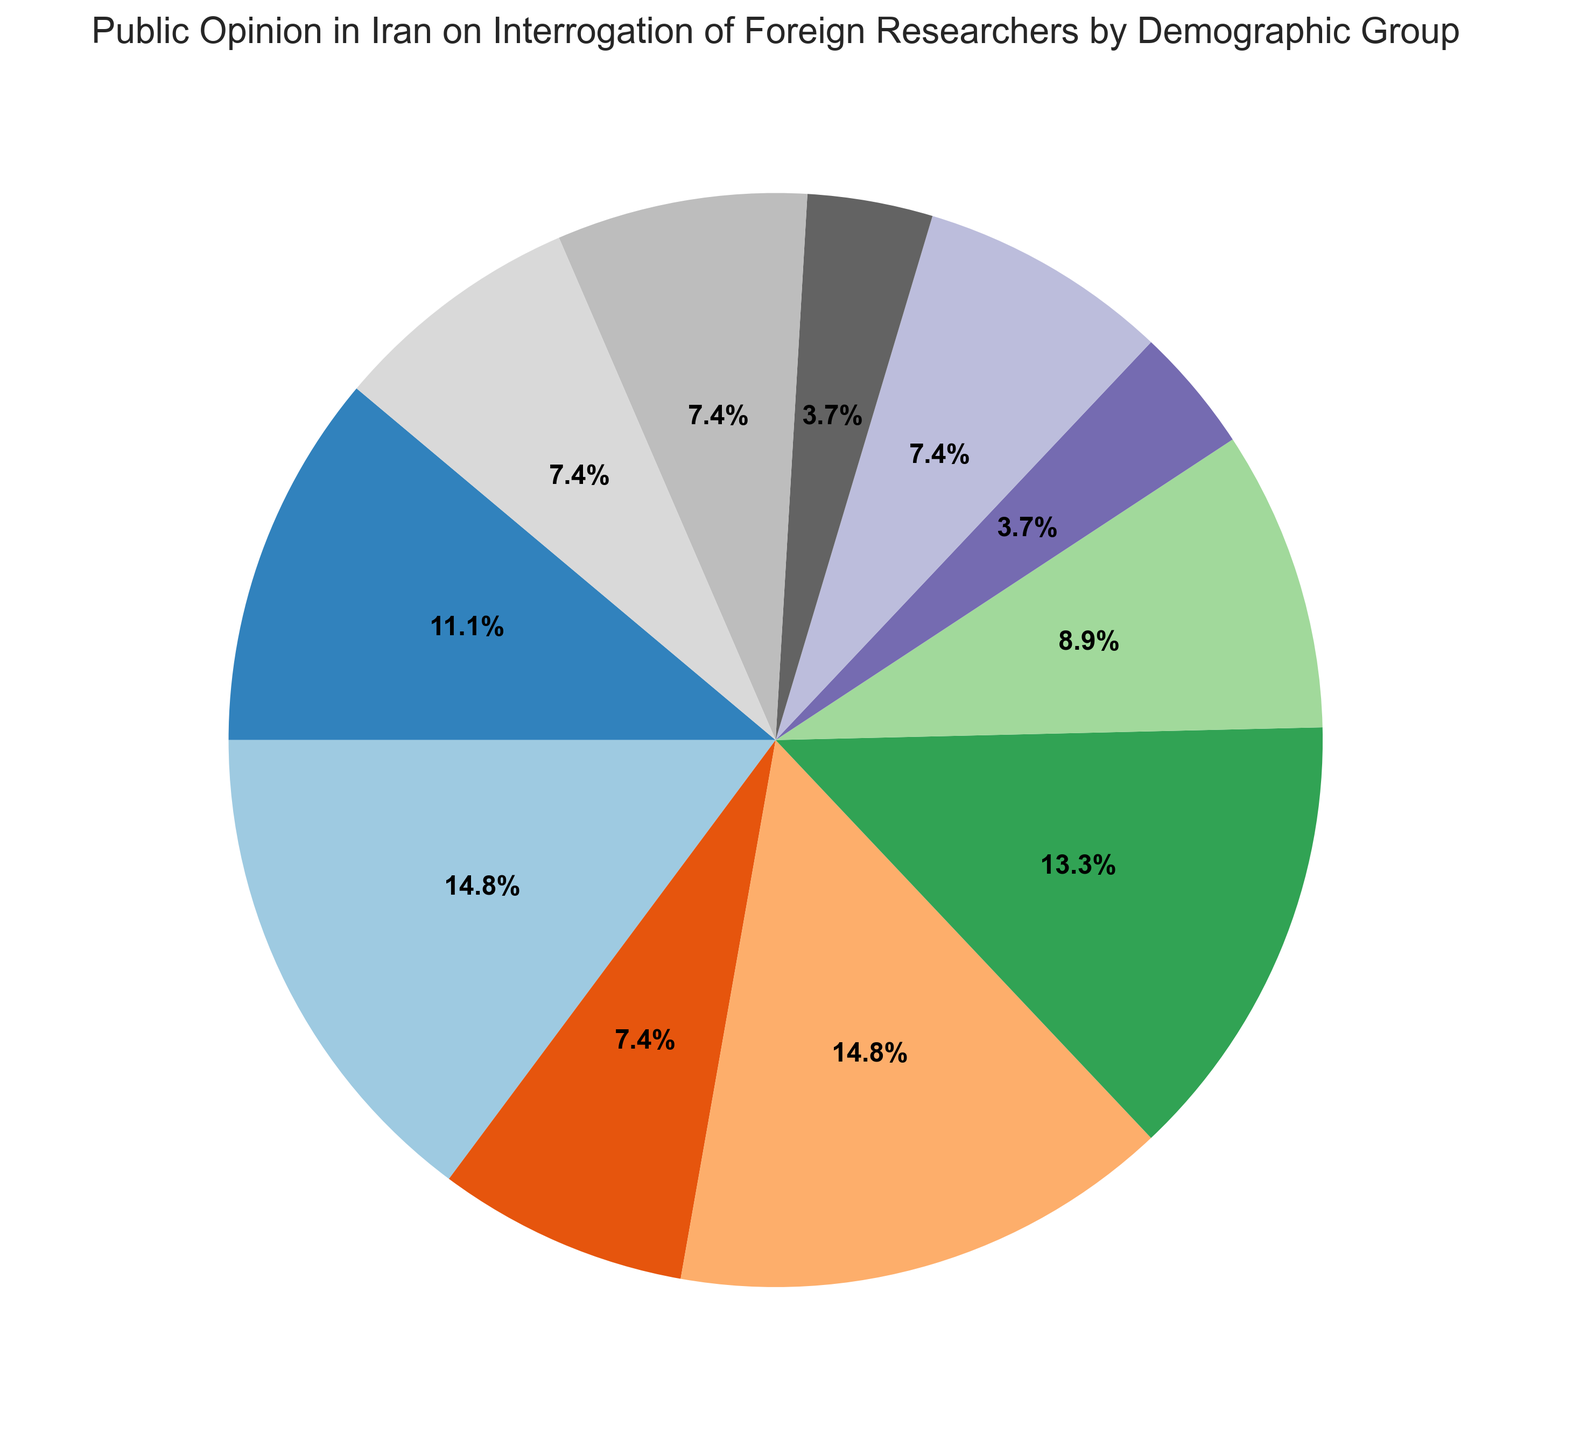Which demographic has the highest percentage of opinion on the interrogation of foreign researchers? Observing the pie chart, the largest wedge or segment corresponds to "Men 30-50" which has a 20% share.
Answer: Men 30-50 Which two demographic groups have the same percentage of opinion, and what is the percentage? By examining the pie chart, it's evident that "Rural residents," "Moderately educated," and "Lowly educated" each hold a 10% share.
Answer: Rural residents and Moderately educated with 10% How does the percentage of opinion for "Women under 30" compare with "Men over 50"? The pie chart shows that "Women under 30" have a percentage of 20%, while "Men over 50" have a percentage of 10%. Therefore, "Women under 30" have double the percentage of "Men over 50".
Answer: Women under 30 have double the percentage of Men over 50 What is the combined percentage for all women demographic groups? The pie chart reveals the percentages for "Women under 30" (20%), "Women 30-50" (18%), and "Women over 50" (12%). The combined percentage is: 20 + 18 + 12 = 50%.
Answer: 50% Compare the total percentage of opinion between urban and rural residents. The pie chart shows that "Urban residents" have 5% while "Rural residents" have 10%. So, "Rural residents" have 5% more than "Urban residents".
Answer: Rural residents have 5% more than Urban residents What percentage difference exists between "Men 30-50" and "Women 30-50"? According to the pie chart, "Men 30-50" account for 20% and "Women 30-50" account for 18%. The percentage difference is: 20 - 18 = 2%.
Answer: 2% Which demographic groups have the lowest percentage, and what is that percentage? Observing the pie chart carefully, the smallest percentages are for "Urban residents" and "Highly educated" both at 5%.
Answer: Urban residents and Highly educated with 5% What is the total percentage for all men demographic groups? The pie chart indicates the percentages for "Men under 30" (15%), "Men 30-50" (20%), and "Men over 50" (10%). The total percentage is: 15 + 20 + 10 = 45%.
Answer: 45% How does the public opinion of "Women 30-50" compare with "Men under 30"? The chart shows "Women 30-50" at 18% and "Men under 30" at 15%. So "Women 30-50" have a 3% higher share than "Men under 30".
Answer: Women 30-50 are 3% higher than Men under 30 